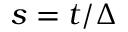<formula> <loc_0><loc_0><loc_500><loc_500>s = t / \Delta</formula> 